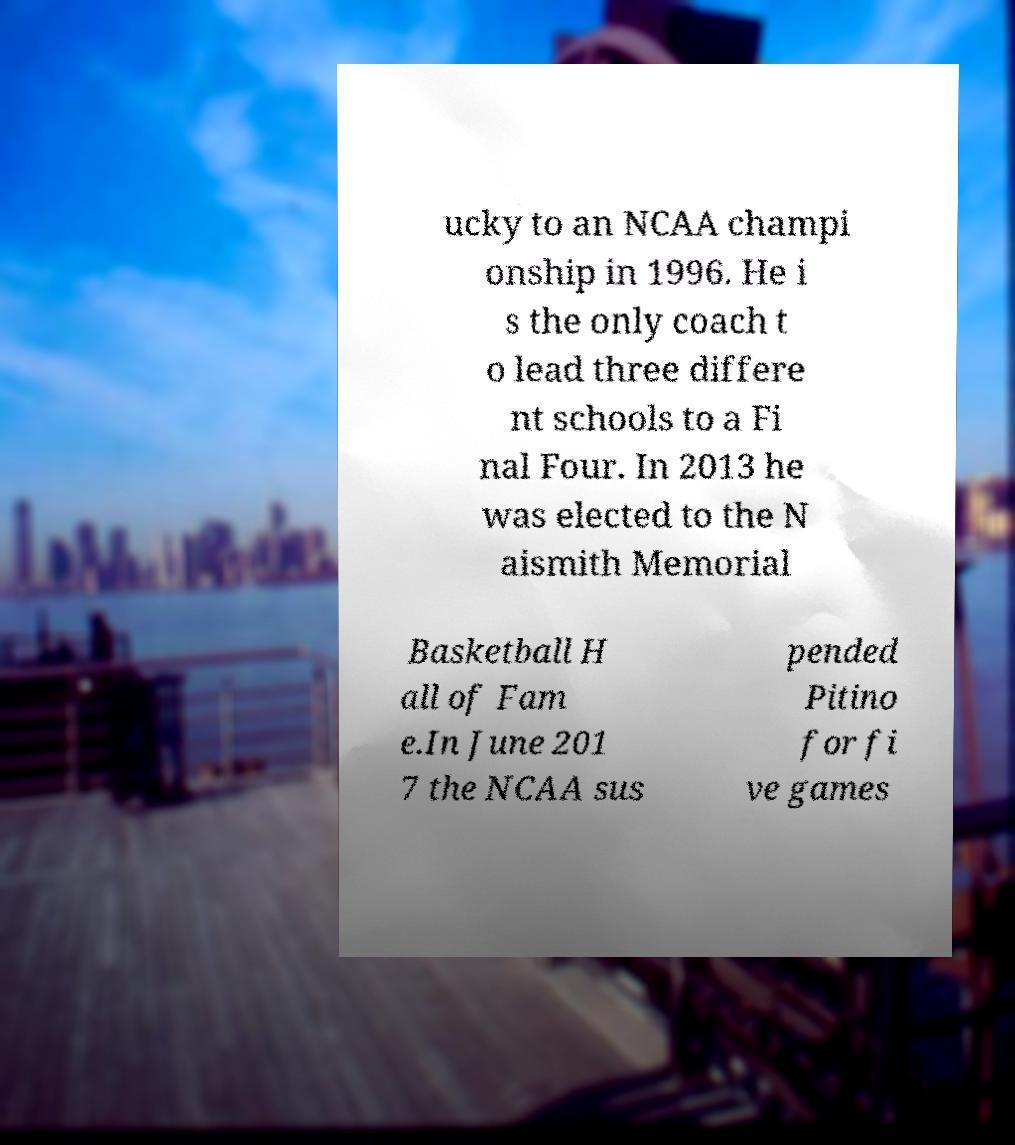What messages or text are displayed in this image? I need them in a readable, typed format. ucky to an NCAA champi onship in 1996. He i s the only coach t o lead three differe nt schools to a Fi nal Four. In 2013 he was elected to the N aismith Memorial Basketball H all of Fam e.In June 201 7 the NCAA sus pended Pitino for fi ve games 